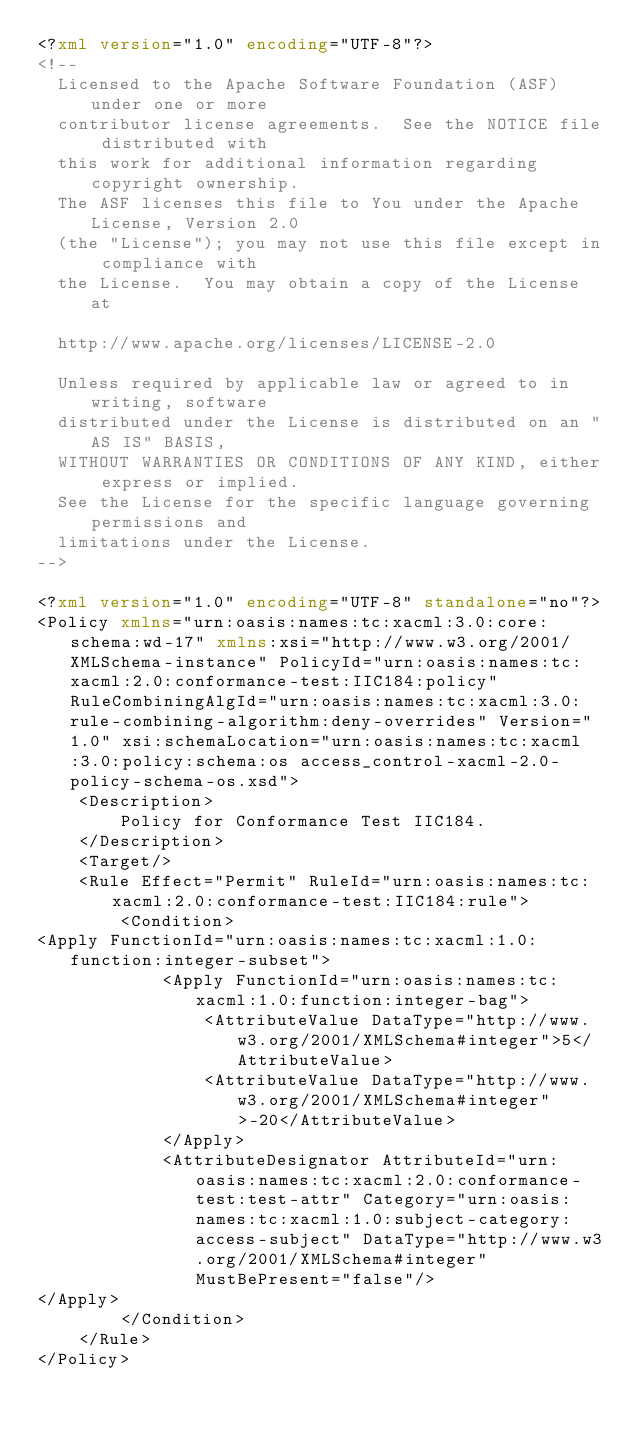<code> <loc_0><loc_0><loc_500><loc_500><_XML_><?xml version="1.0" encoding="UTF-8"?>
<!--
  Licensed to the Apache Software Foundation (ASF) under one or more
  contributor license agreements.  See the NOTICE file distributed with
  this work for additional information regarding copyright ownership.
  The ASF licenses this file to You under the Apache License, Version 2.0
  (the "License"); you may not use this file except in compliance with
  the License.  You may obtain a copy of the License at

  http://www.apache.org/licenses/LICENSE-2.0

  Unless required by applicable law or agreed to in writing, software
  distributed under the License is distributed on an "AS IS" BASIS,
  WITHOUT WARRANTIES OR CONDITIONS OF ANY KIND, either express or implied.
  See the License for the specific language governing permissions and
  limitations under the License.
-->

<?xml version="1.0" encoding="UTF-8" standalone="no"?>
<Policy xmlns="urn:oasis:names:tc:xacml:3.0:core:schema:wd-17" xmlns:xsi="http://www.w3.org/2001/XMLSchema-instance" PolicyId="urn:oasis:names:tc:xacml:2.0:conformance-test:IIC184:policy" RuleCombiningAlgId="urn:oasis:names:tc:xacml:3.0:rule-combining-algorithm:deny-overrides" Version="1.0" xsi:schemaLocation="urn:oasis:names:tc:xacml:3.0:policy:schema:os access_control-xacml-2.0-policy-schema-os.xsd">
    <Description>
        Policy for Conformance Test IIC184.
    </Description>
    <Target/>
    <Rule Effect="Permit" RuleId="urn:oasis:names:tc:xacml:2.0:conformance-test:IIC184:rule">
        <Condition>
<Apply FunctionId="urn:oasis:names:tc:xacml:1.0:function:integer-subset">
            <Apply FunctionId="urn:oasis:names:tc:xacml:1.0:function:integer-bag">
                <AttributeValue DataType="http://www.w3.org/2001/XMLSchema#integer">5</AttributeValue>
                <AttributeValue DataType="http://www.w3.org/2001/XMLSchema#integer">-20</AttributeValue>
            </Apply>
            <AttributeDesignator AttributeId="urn:oasis:names:tc:xacml:2.0:conformance-test:test-attr" Category="urn:oasis:names:tc:xacml:1.0:subject-category:access-subject" DataType="http://www.w3.org/2001/XMLSchema#integer" MustBePresent="false"/>
</Apply>
        </Condition>
    </Rule>
</Policy>
</code> 